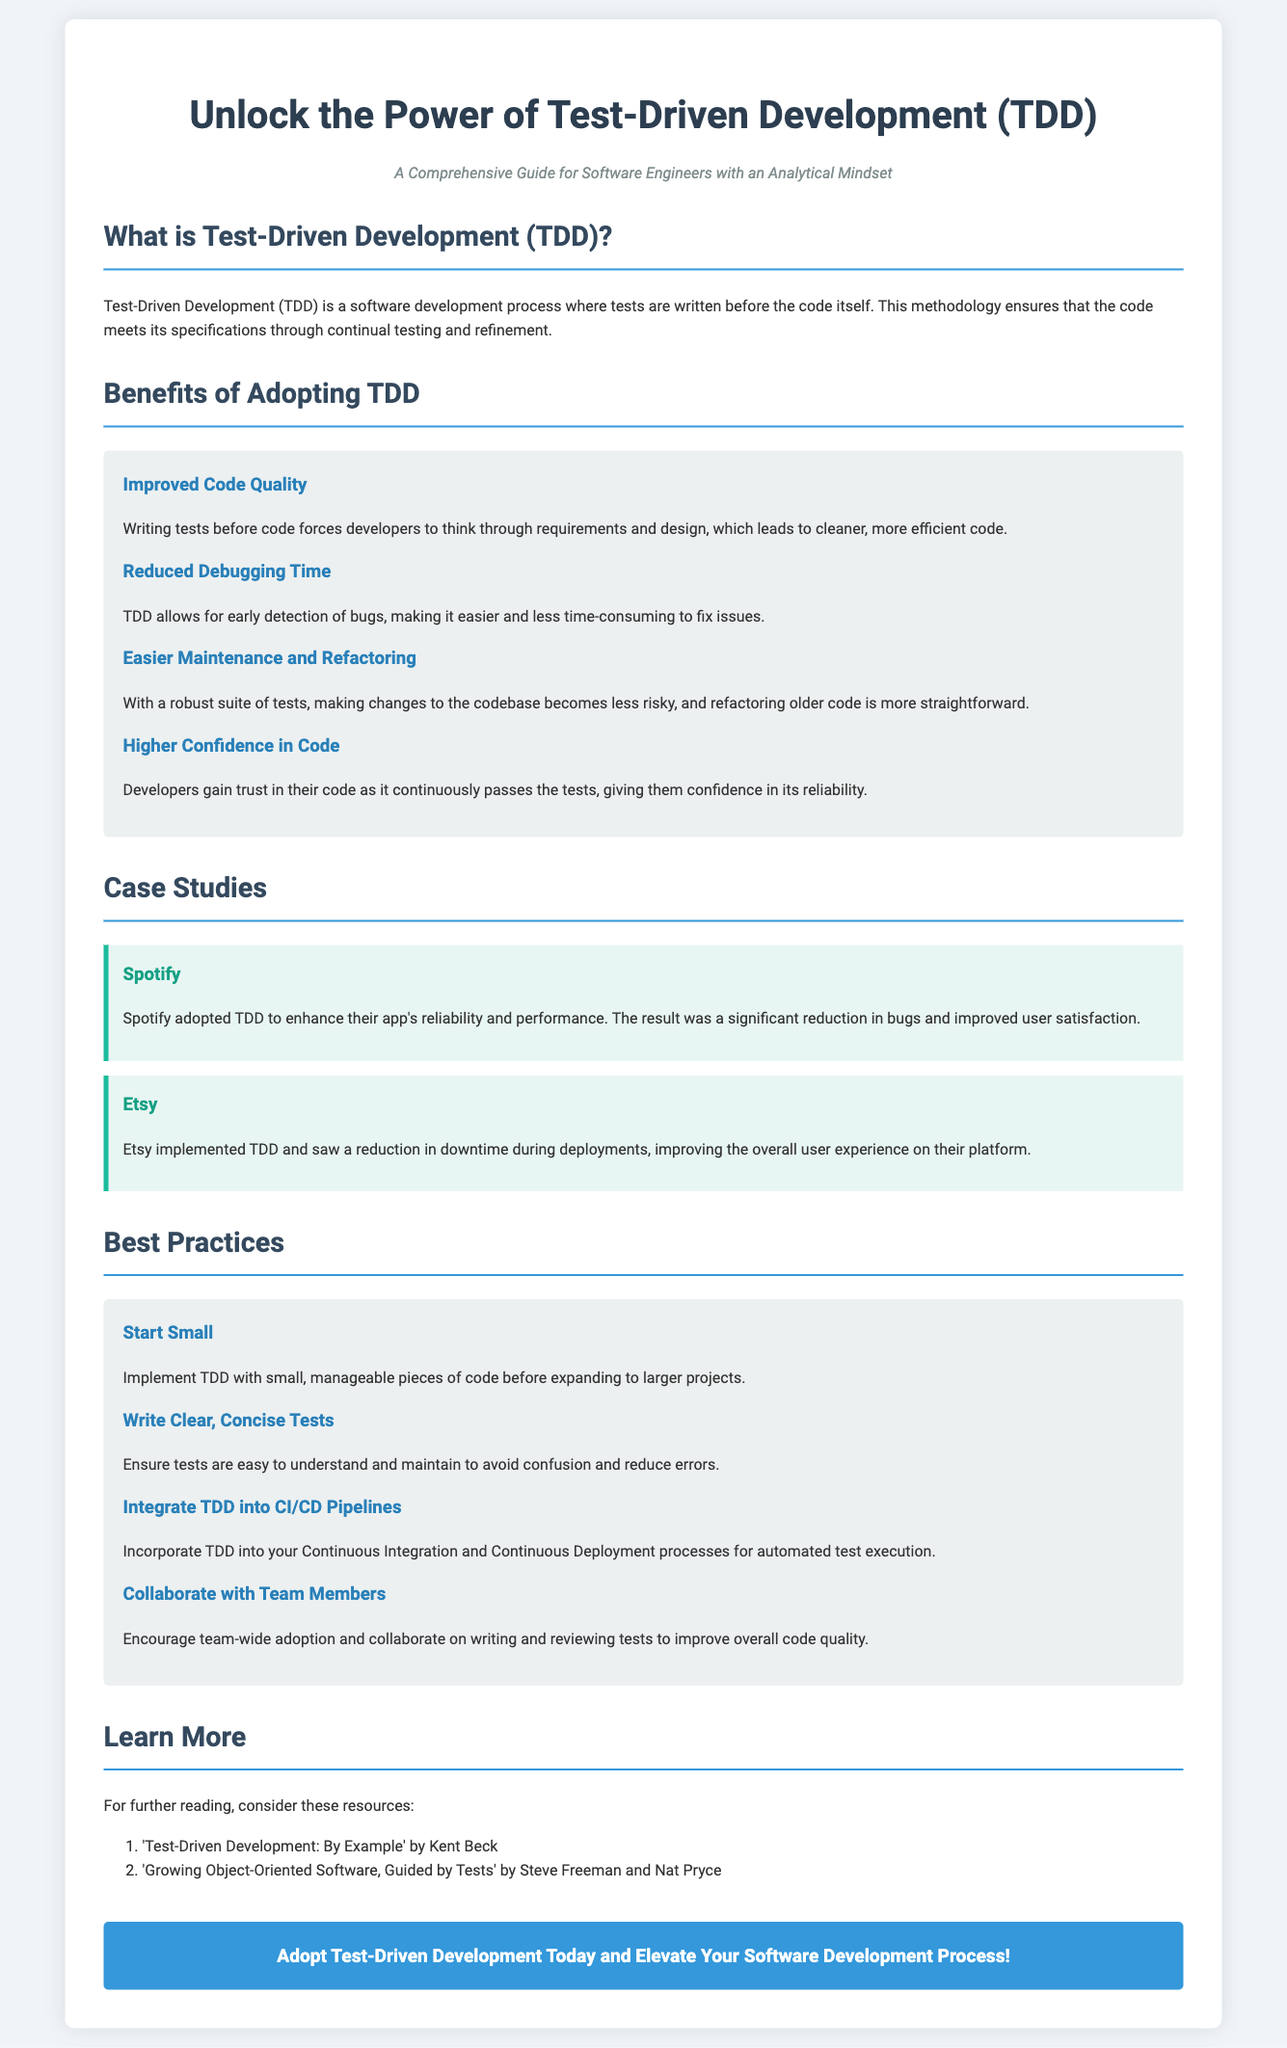What is TDD? TDD is a software development process where tests are written before the code itself.
Answer: A software development process where tests are written before the code itself What is one benefit of adopting TDD? The document lists several benefits, including improved code quality, reduced debugging time, easier maintenance, and higher confidence in code.
Answer: Improved code quality Which company adopted TDD to enhance app reliability? The case studies mention companies that adopted TDD, specifically highlighting Spotify.
Answer: Spotify How does TDD impact debugging time? The document states that TDD allows for early detection of bugs, making it easier and less time-consuming to fix issues.
Answer: Reduced debugging time What is a recommended best practice for implementing TDD? The document outlines several best practices, including starting small, writing clear tests, and collaborating with team members.
Answer: Start small How many case studies are included in the document? The document presents two case studies related to TDD implementation.
Answer: Two Who is the author of "Test-Driven Development: By Example"? The document lists authors of recommended resources, with Kent Beck being the author of that book.
Answer: Kent Beck What color is used for the section headings? The document specifies colors for section headings, stating that section headings are colored dark blue.
Answer: Dark blue What is the tagline of the flyer? The document includes a tagline that emphasizes the target audience and purpose of the guide.
Answer: A Comprehensive Guide for Software Engineers with an Analytical Mindset 